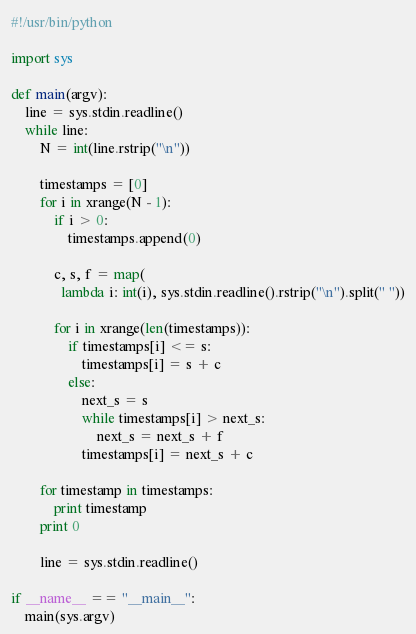<code> <loc_0><loc_0><loc_500><loc_500><_Python_>#!/usr/bin/python

import sys

def main(argv):
    line = sys.stdin.readline()
    while line:
        N = int(line.rstrip("\n"))

        timestamps = [0]
        for i in xrange(N - 1):
            if i > 0:
                timestamps.append(0)

            c, s, f = map(
              lambda i: int(i), sys.stdin.readline().rstrip("\n").split(" "))

            for i in xrange(len(timestamps)):
                if timestamps[i] <= s:
                    timestamps[i] = s + c
                else:
                    next_s = s
                    while timestamps[i] > next_s:
                        next_s = next_s + f
                    timestamps[i] = next_s + c

        for timestamp in timestamps:
            print timestamp
        print 0

        line = sys.stdin.readline()

if __name__ == "__main__":
    main(sys.argv)</code> 